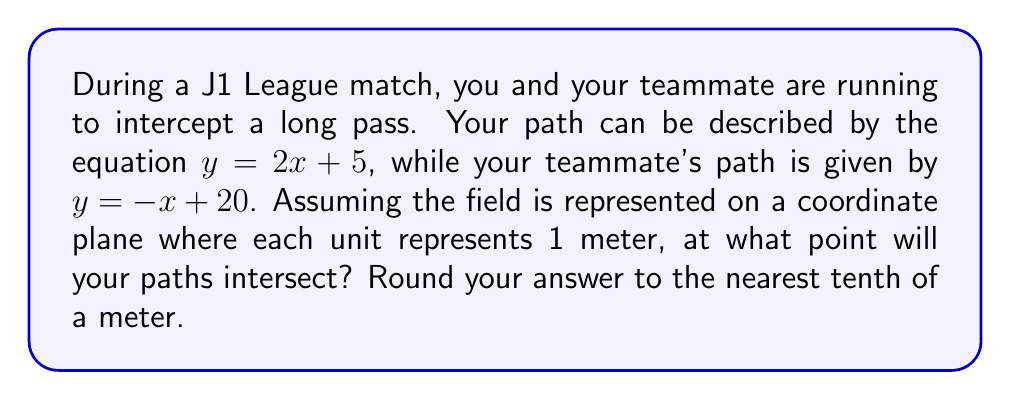Can you answer this question? To find the intersection point of the two paths, we need to solve the system of equations:

$$\begin{cases}
y = 2x + 5 \\
y = -x + 20
\end{cases}$$

1) Since both equations are equal to $y$, we can set them equal to each other:

   $2x + 5 = -x + 20$

2) Add $x$ to both sides:

   $3x + 5 = 20$

3) Subtract 5 from both sides:

   $3x = 15$

4) Divide both sides by 3:

   $x = 5$

5) Now that we know $x$, we can substitute it into either of the original equations to find $y$. Let's use the first equation:

   $y = 2x + 5$
   $y = 2(5) + 5$
   $y = 10 + 5 = 15$

6) Therefore, the intersection point is $(5, 15)$.

7) As each unit represents 1 meter, and we're asked to round to the nearest tenth of a meter, our final answer is $(5.0, 15.0)$.

[asy]
unitsize(1cm);
defaultpen(fontsize(10pt));

// Draw axes
draw((-1,0)--(7,0), arrow=Arrow(TeXHead));
draw((0,-1)--(0,21), arrow=Arrow(TeXHead));

// Label axes
label("$x$", (7,0), E);
label("$y$", (0,21), N);

// Draw lines
draw((0,5)--(5,15)--(7,19), blue);
draw((0,20)--(5,15)--(7,13), red);

// Label lines
label("$y = 2x + 5$", (6,17), NW, blue);
label("$y = -x + 20$", (6,14), SE, red);

// Mark intersection point
dot((5,15), red);
label("(5, 15)", (5,15), NE);

[/asy]
Answer: $(5.0, 15.0)$ 